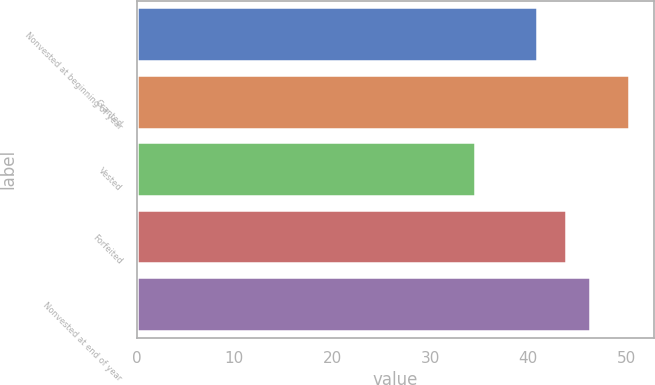Convert chart to OTSL. <chart><loc_0><loc_0><loc_500><loc_500><bar_chart><fcel>Nonvested at beginning of year<fcel>Granted<fcel>Vested<fcel>Forfeited<fcel>Nonvested at end of year<nl><fcel>40.88<fcel>50.34<fcel>34.56<fcel>43.87<fcel>46.33<nl></chart> 